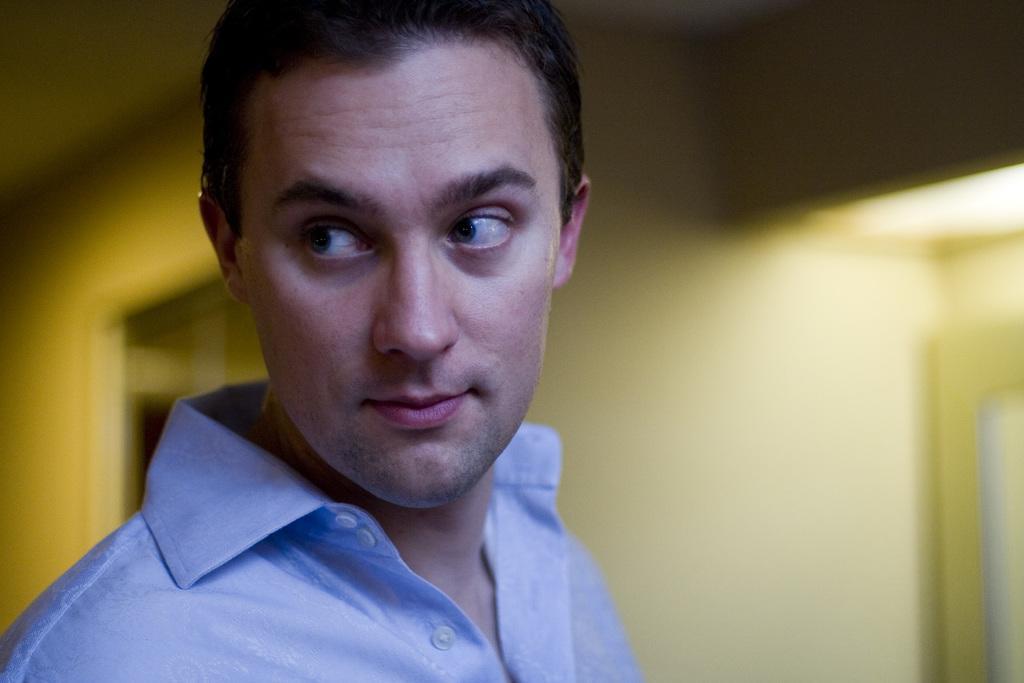Can you describe this image briefly? In this picture I can see a man, He wore a blue shirt and I can see inner view of a house. 